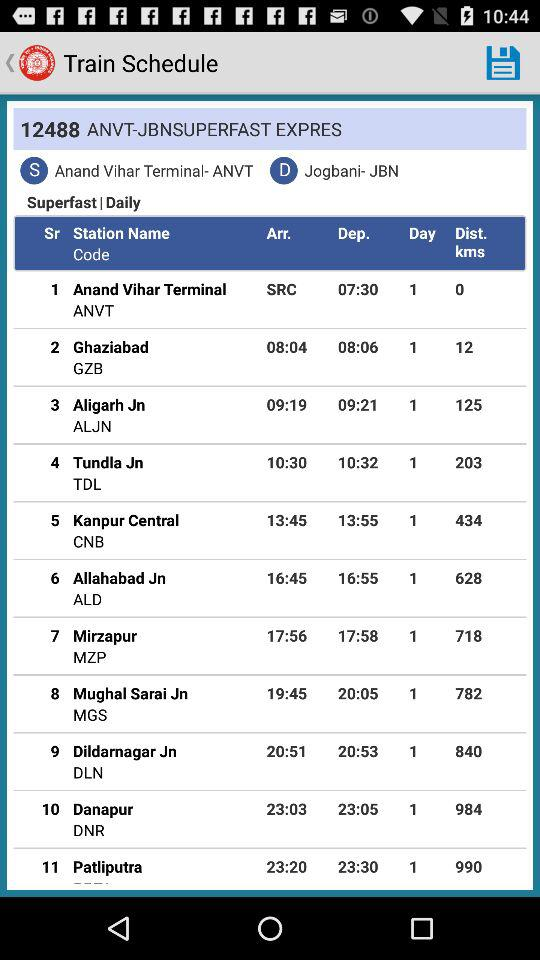What is the arrival time at Patliputra station? The arrival time is 23:20. 